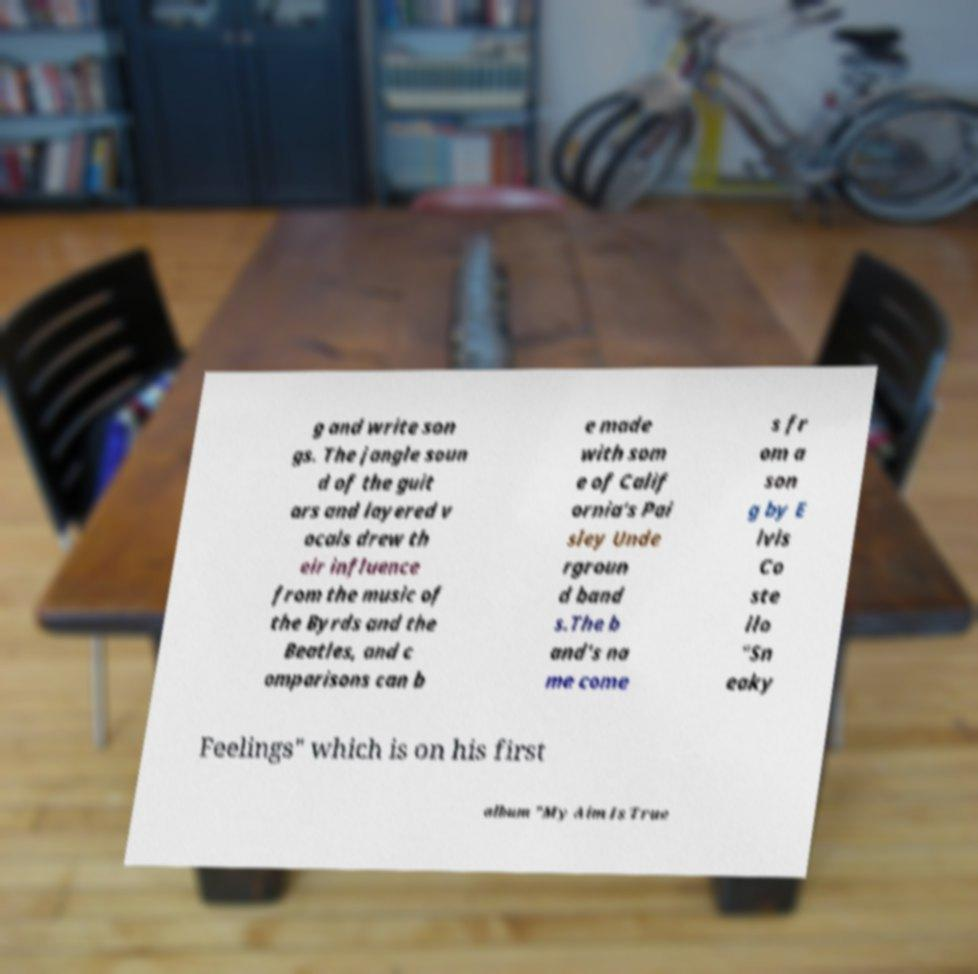I need the written content from this picture converted into text. Can you do that? g and write son gs. The jangle soun d of the guit ars and layered v ocals drew th eir influence from the music of the Byrds and the Beatles, and c omparisons can b e made with som e of Calif ornia's Pai sley Unde rgroun d band s.The b and's na me come s fr om a son g by E lvis Co ste llo "Sn eaky Feelings" which is on his first album "My Aim Is True 